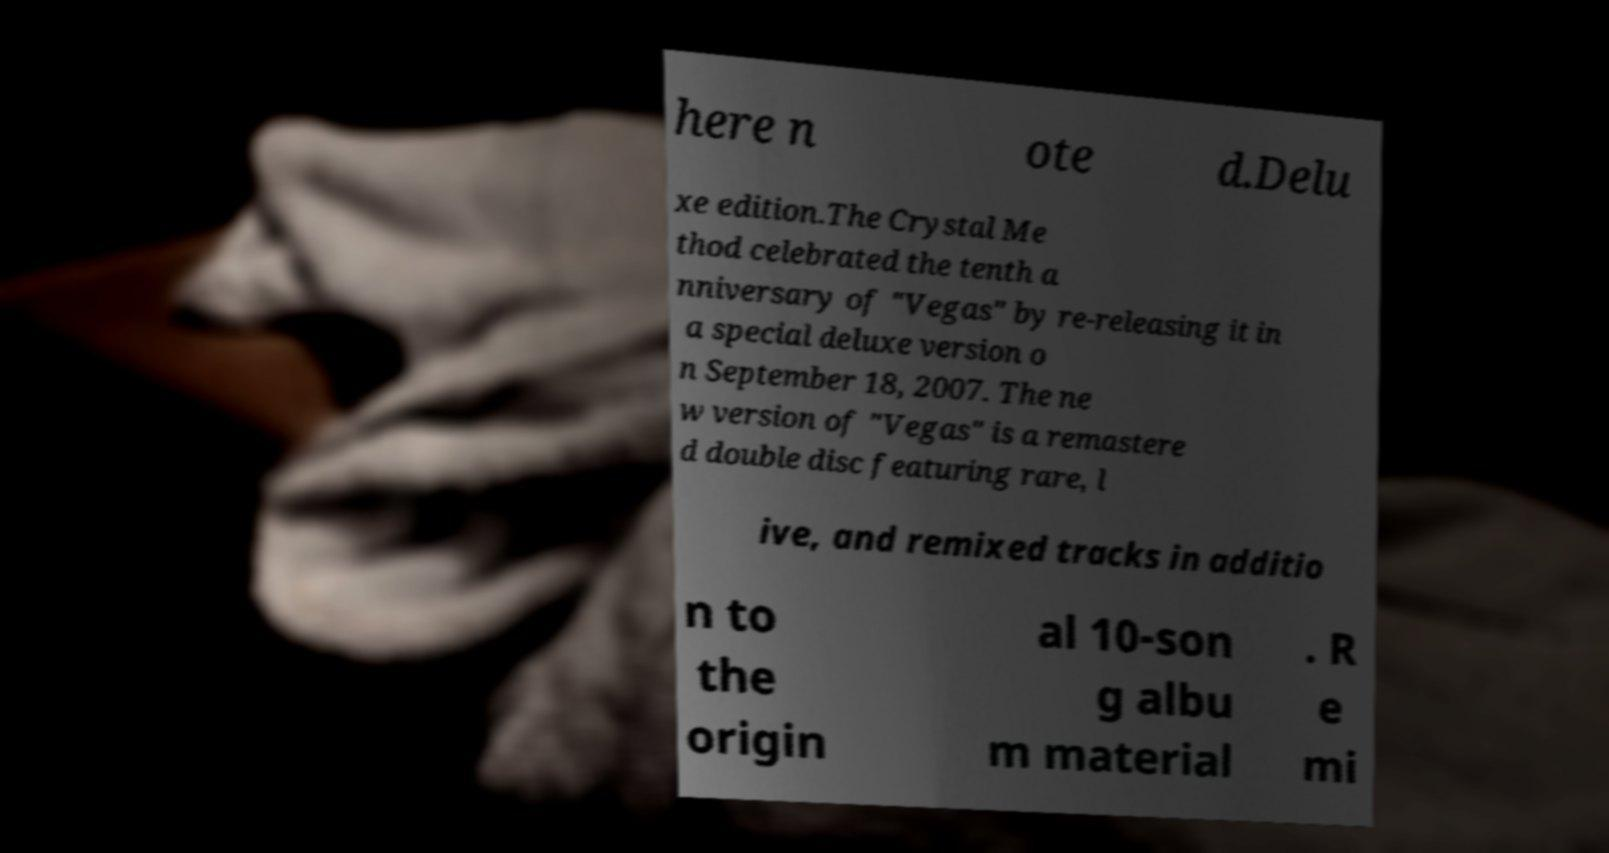Could you assist in decoding the text presented in this image and type it out clearly? here n ote d.Delu xe edition.The Crystal Me thod celebrated the tenth a nniversary of "Vegas" by re-releasing it in a special deluxe version o n September 18, 2007. The ne w version of "Vegas" is a remastere d double disc featuring rare, l ive, and remixed tracks in additio n to the origin al 10-son g albu m material . R e mi 